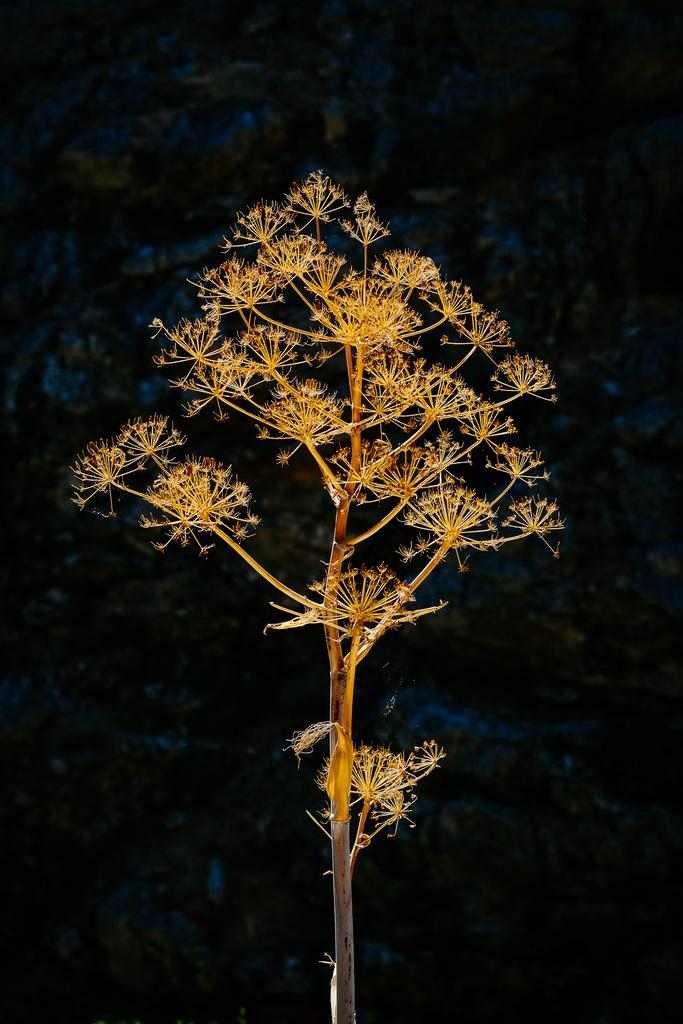What is the main subject of the image? The main subject of the image is a plant. What specific feature can be observed on the plant? The plant has tiny flowers. What can be said about the background of the image? The background of the image is dark. What type of vein is visible in the image? There is no vein visible in the image; it features a plant with tiny flowers. How does the plant affect the acoustics in the room? The image does not provide information about the acoustics in the room, as it only shows a plant with tiny flowers and a dark background. 